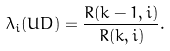<formula> <loc_0><loc_0><loc_500><loc_500>\lambda _ { i } ( U D ) = \frac { R ( k - 1 , i ) } { R ( k , i ) } .</formula> 